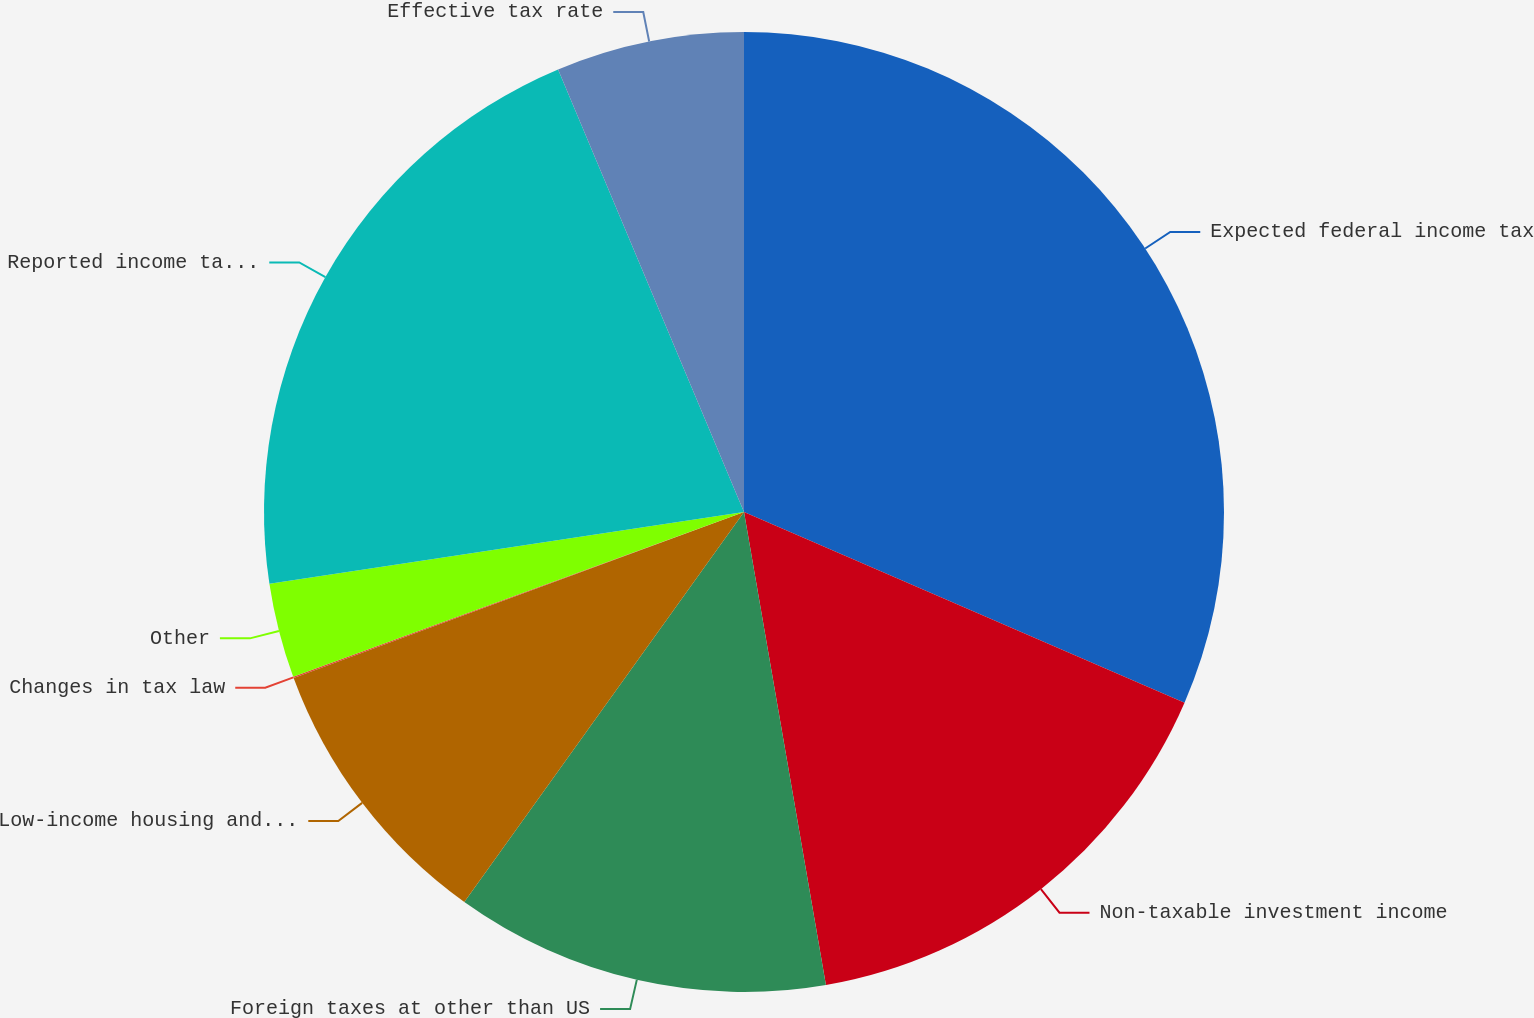Convert chart. <chart><loc_0><loc_0><loc_500><loc_500><pie_chart><fcel>Expected federal income tax<fcel>Non-taxable investment income<fcel>Foreign taxes at other than US<fcel>Low-income housing and other<fcel>Changes in tax law<fcel>Other<fcel>Reported income tax expense<fcel>Effective tax rate<nl><fcel>31.5%<fcel>15.77%<fcel>12.63%<fcel>9.48%<fcel>0.04%<fcel>3.19%<fcel>21.06%<fcel>6.33%<nl></chart> 